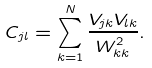Convert formula to latex. <formula><loc_0><loc_0><loc_500><loc_500>C _ { j l } = \sum _ { k = 1 } ^ { N } \frac { V _ { j k } V _ { l k } } { W _ { k k } ^ { 2 } } .</formula> 